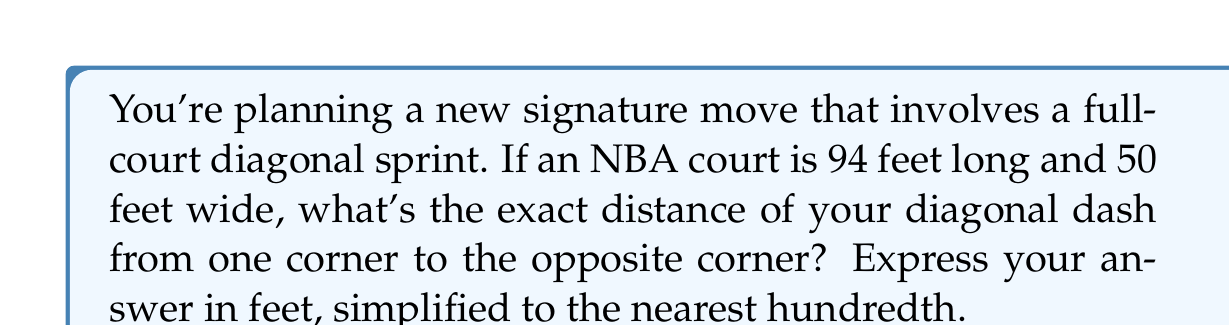Could you help me with this problem? Let's approach this step-by-step:

1) The basketball court forms a rectangle. The diagonal of this rectangle can be found using the Pythagorean theorem.

2) Let's call the diagonal distance $d$. According to the Pythagorean theorem:

   $$d^2 = 94^2 + 50^2$$

3) Let's calculate the right side:
   $$d^2 = 8836 + 2500 = 11336$$

4) Now, to find $d$, we need to take the square root of both sides:
   $$d = \sqrt{11336}$$

5) Using a calculator or computer to evaluate this:
   $$d \approx 106.4708$$

6) Rounding to the nearest hundredth:
   $$d \approx 106.47\text{ feet}$$

[asy]
import geometry;

pair A=(0,0), B=(94,0), C=(94,50), D=(0,50);
draw(A--B--C--D--cycle);
draw(A--C,dashed);

label("94 ft", (47,-5));
label("50 ft", (99,25), E);
label("d", (47,25), NW);

dot("A", A, SW);
dot("C", C, NE);
[/asy]
Answer: 106.47 feet 